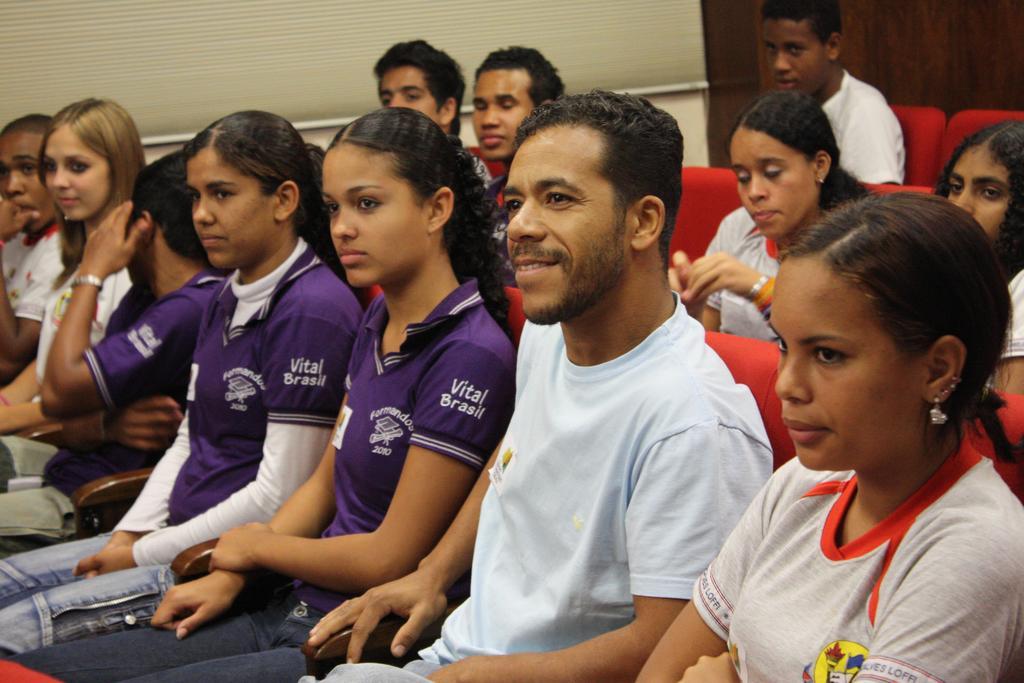Please provide a concise description of this image. In this image we can see men and women are sitting on the red color seats. Behind them, white and brown color wall is there. 